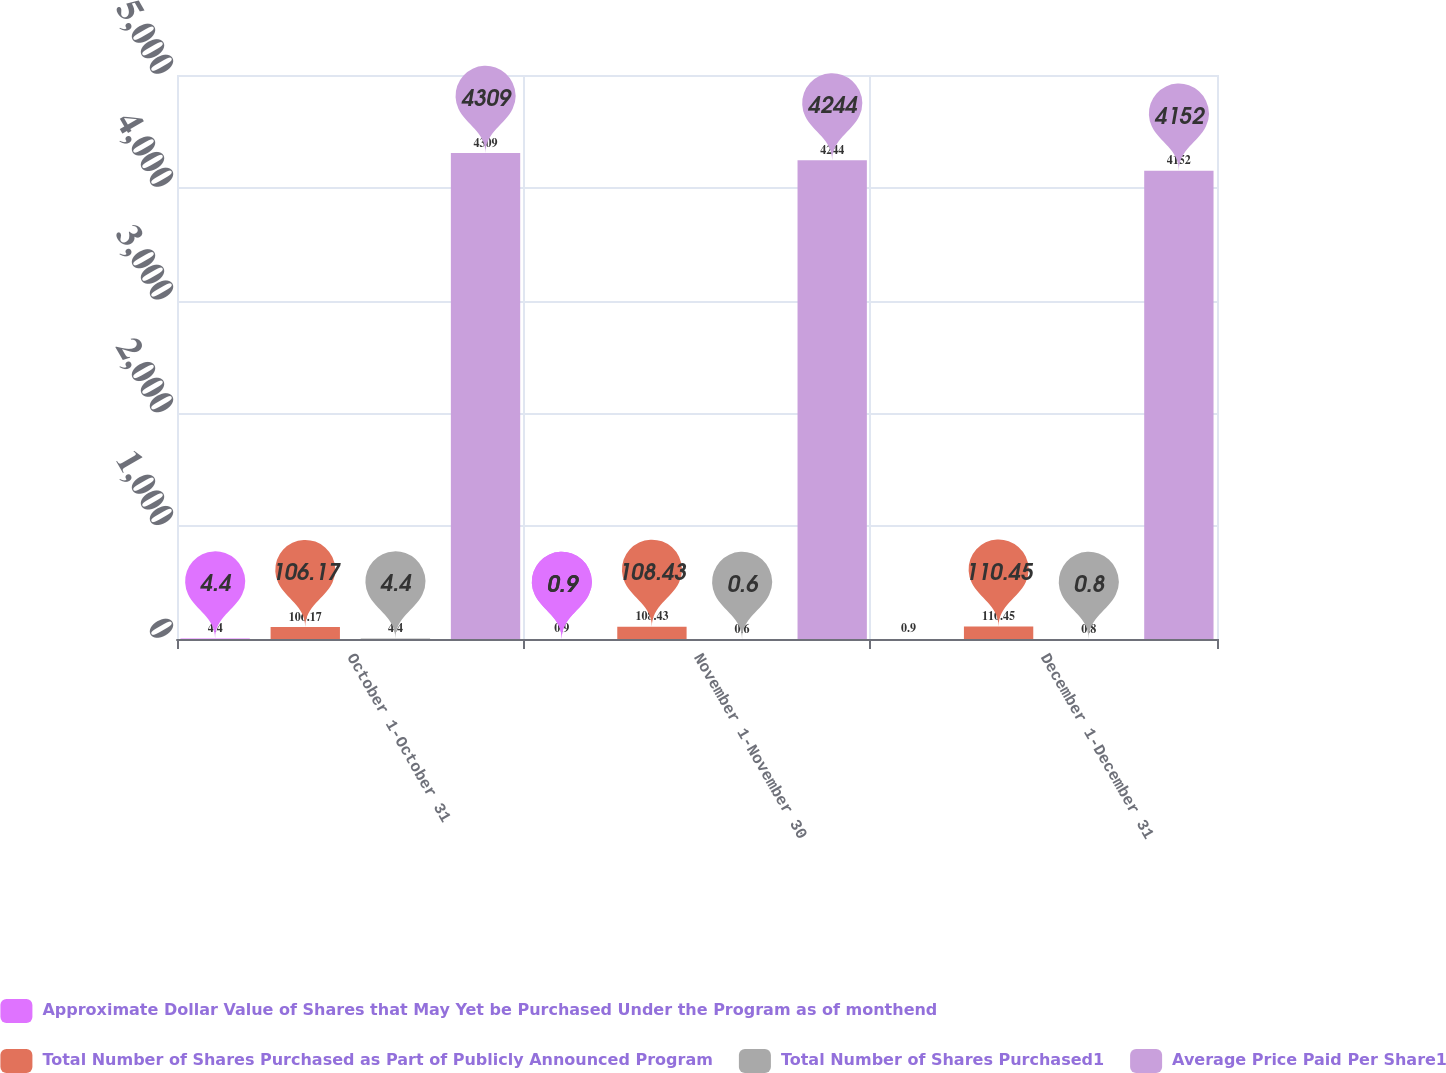Convert chart. <chart><loc_0><loc_0><loc_500><loc_500><stacked_bar_chart><ecel><fcel>October 1-October 31<fcel>November 1-November 30<fcel>December 1-December 31<nl><fcel>Approximate Dollar Value of Shares that May Yet be Purchased Under the Program as of monthend<fcel>4.4<fcel>0.9<fcel>0.9<nl><fcel>Total Number of Shares Purchased as Part of Publicly Announced Program<fcel>106.17<fcel>108.43<fcel>110.45<nl><fcel>Total Number of Shares Purchased1<fcel>4.4<fcel>0.6<fcel>0.8<nl><fcel>Average Price Paid Per Share1<fcel>4309<fcel>4244<fcel>4152<nl></chart> 